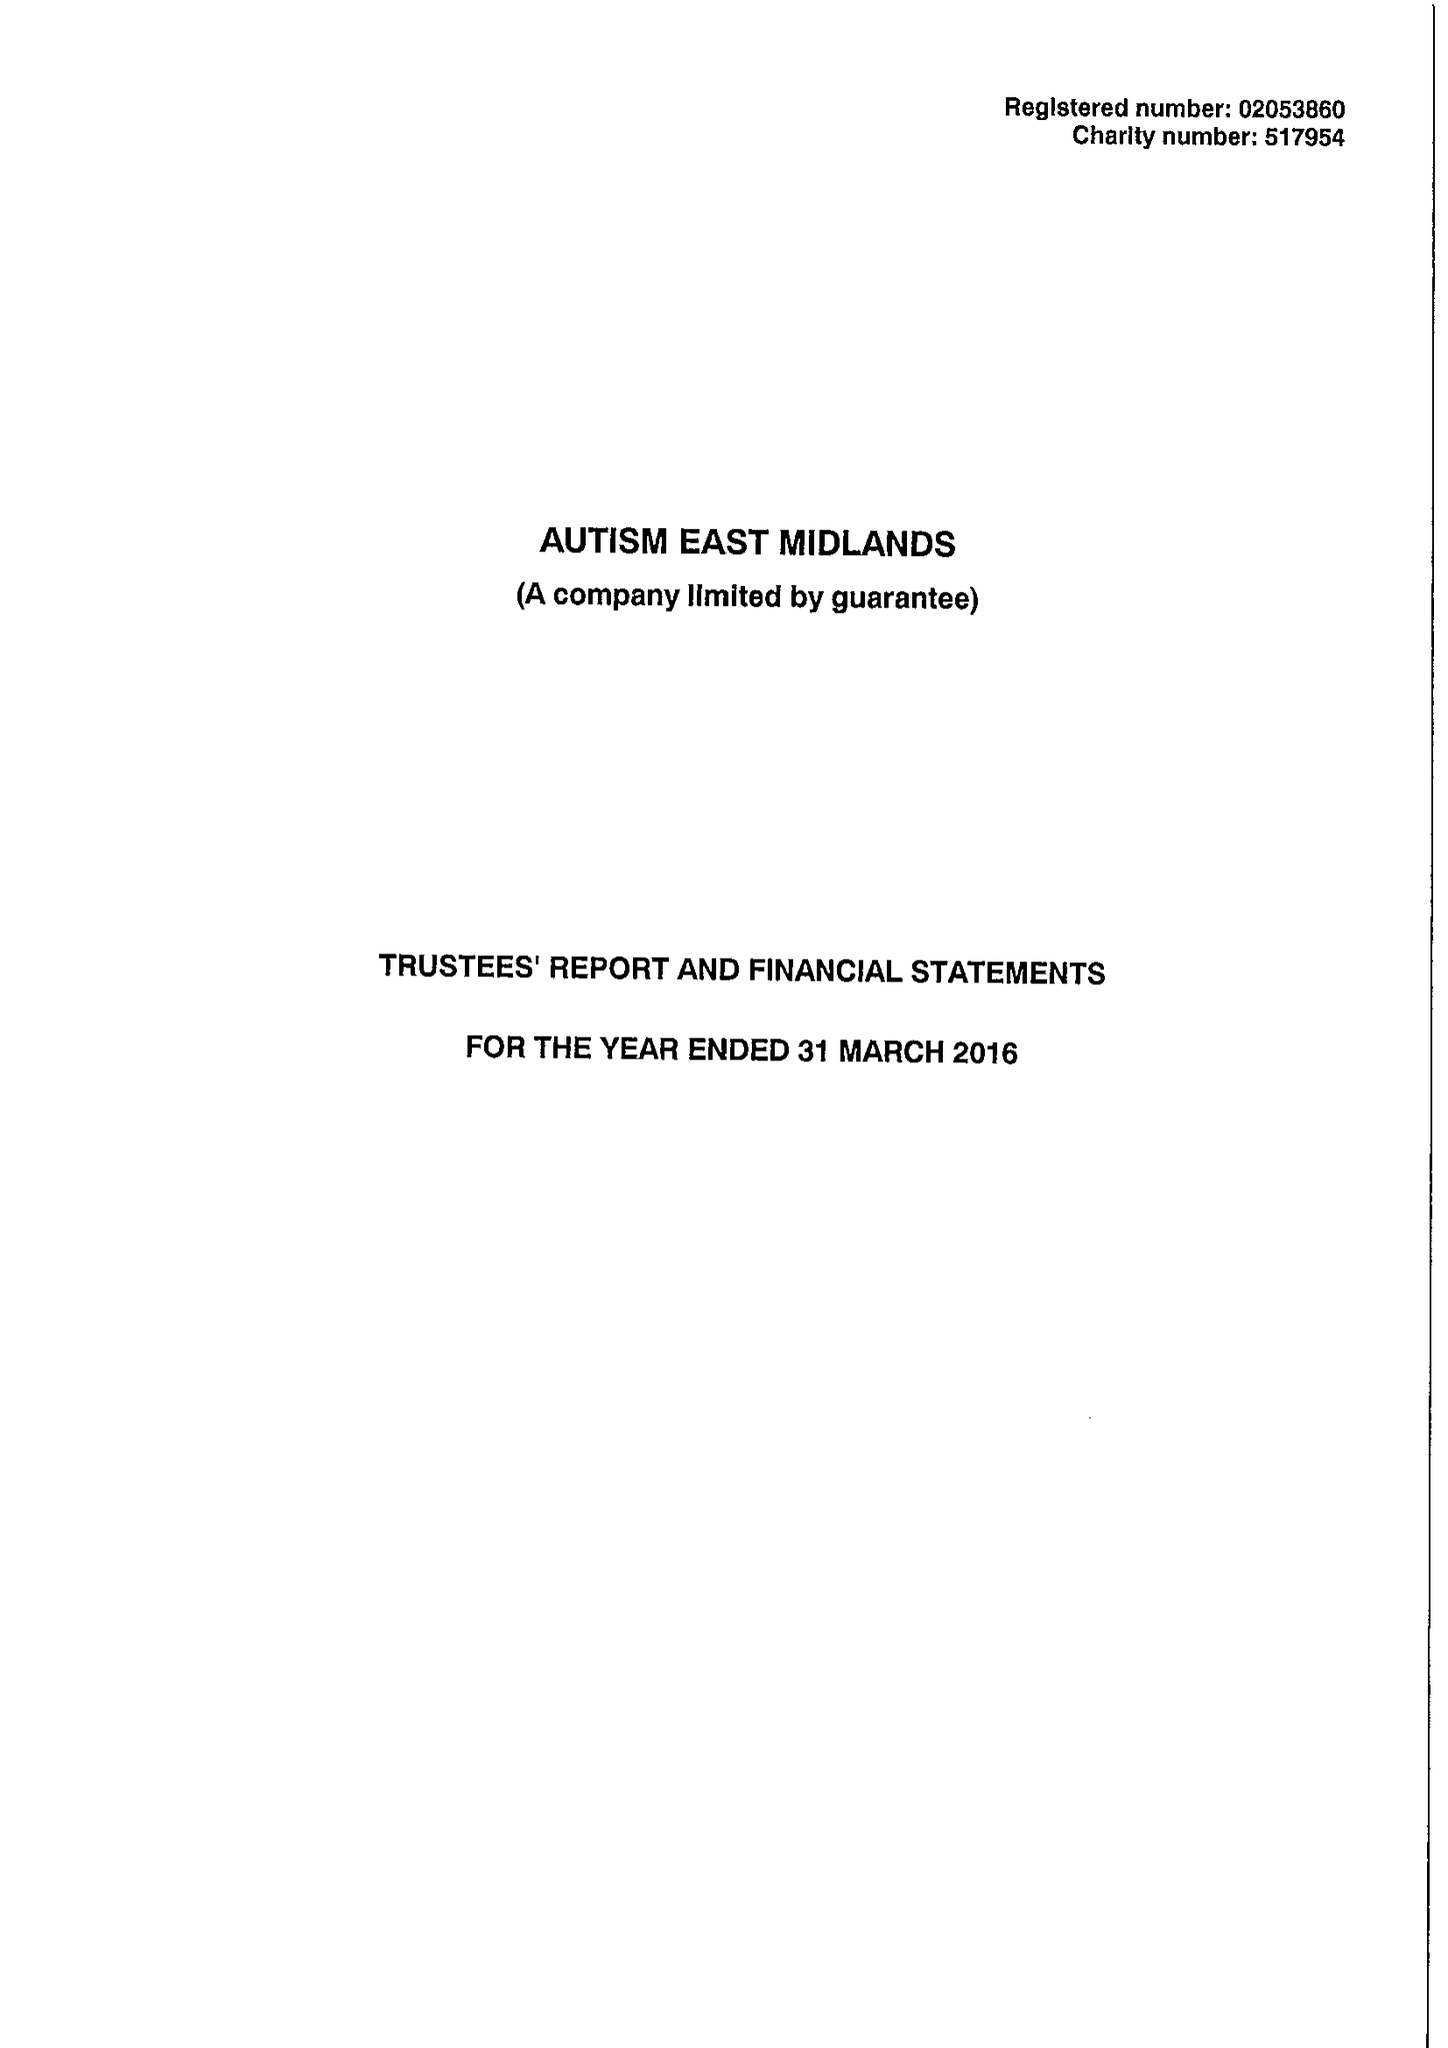What is the value for the address__postcode?
Answer the question using a single word or phrase. S80 4AJ 